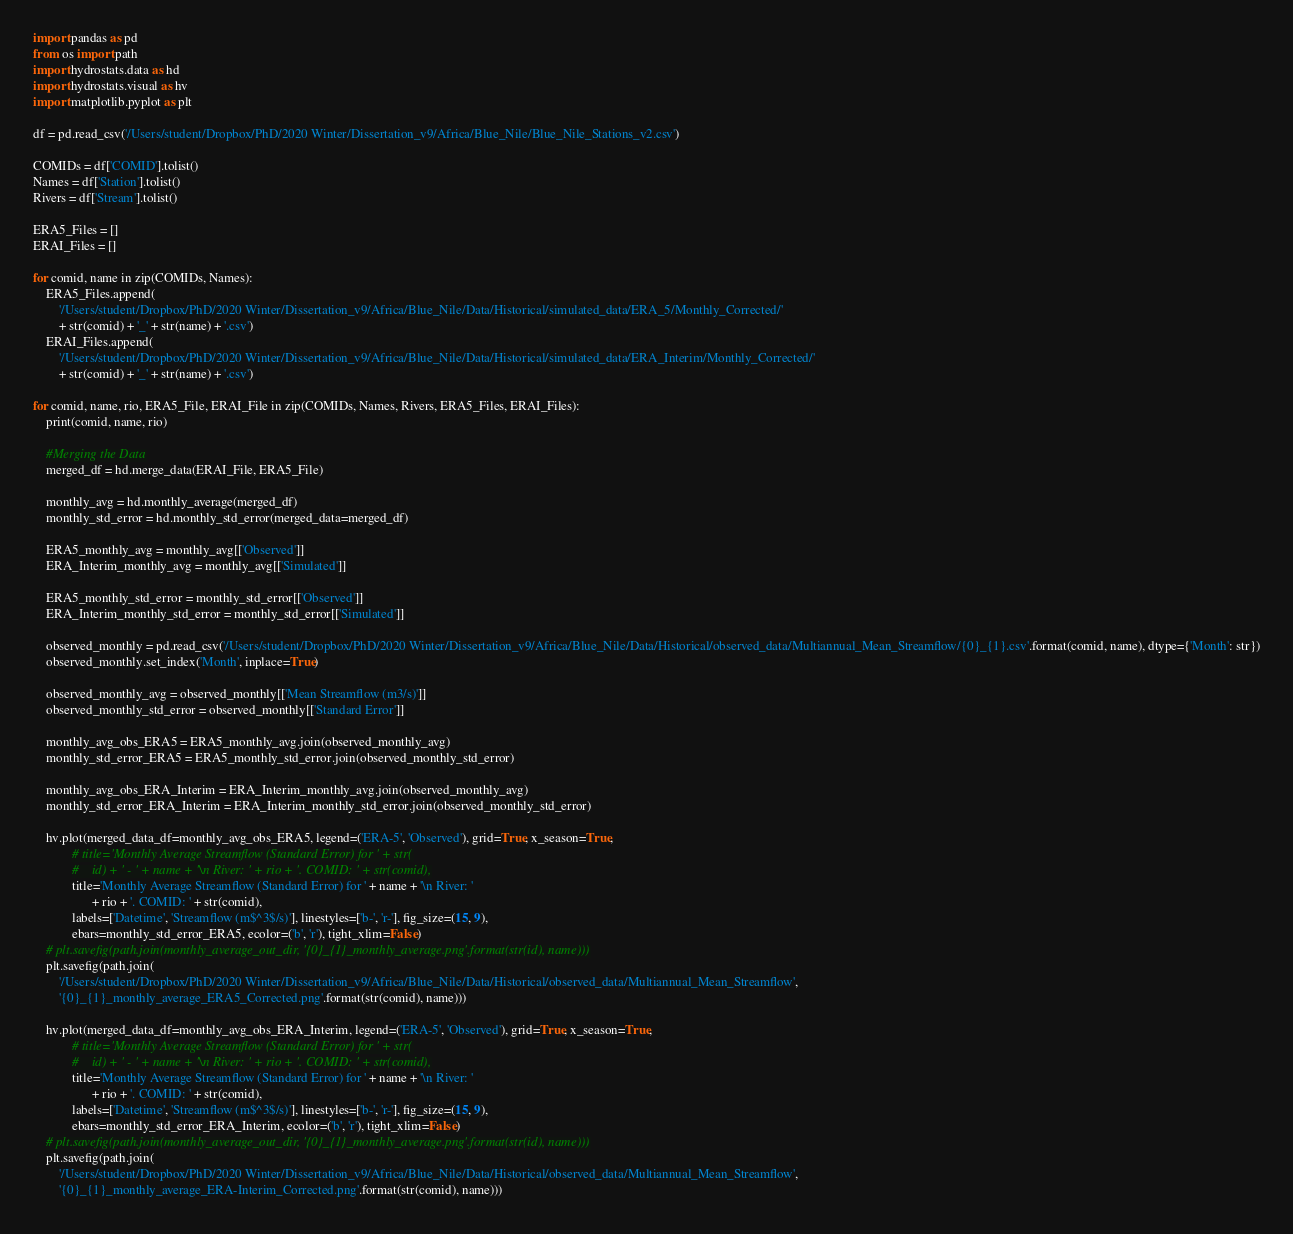Convert code to text. <code><loc_0><loc_0><loc_500><loc_500><_Python_>import pandas as pd
from os import path
import hydrostats.data as hd
import hydrostats.visual as hv
import matplotlib.pyplot as plt

df = pd.read_csv('/Users/student/Dropbox/PhD/2020 Winter/Dissertation_v9/Africa/Blue_Nile/Blue_Nile_Stations_v2.csv')

COMIDs = df['COMID'].tolist()
Names = df['Station'].tolist()
Rivers = df['Stream'].tolist()

ERA5_Files = []
ERAI_Files = []

for comid, name in zip(COMIDs, Names):
	ERA5_Files.append(
		'/Users/student/Dropbox/PhD/2020 Winter/Dissertation_v9/Africa/Blue_Nile/Data/Historical/simulated_data/ERA_5/Monthly_Corrected/'
		+ str(comid) + '_' + str(name) + '.csv')
	ERAI_Files.append(
		'/Users/student/Dropbox/PhD/2020 Winter/Dissertation_v9/Africa/Blue_Nile/Data/Historical/simulated_data/ERA_Interim/Monthly_Corrected/'
		+ str(comid) + '_' + str(name) + '.csv')

for comid, name, rio, ERA5_File, ERAI_File in zip(COMIDs, Names, Rivers, ERA5_Files, ERAI_Files):
	print(comid, name, rio)

	#Merging the Data
	merged_df = hd.merge_data(ERAI_File, ERA5_File)

	monthly_avg = hd.monthly_average(merged_df)
	monthly_std_error = hd.monthly_std_error(merged_data=merged_df)

	ERA5_monthly_avg = monthly_avg[['Observed']]
	ERA_Interim_monthly_avg = monthly_avg[['Simulated']]

	ERA5_monthly_std_error = monthly_std_error[['Observed']]
	ERA_Interim_monthly_std_error = monthly_std_error[['Simulated']]

	observed_monthly = pd.read_csv('/Users/student/Dropbox/PhD/2020 Winter/Dissertation_v9/Africa/Blue_Nile/Data/Historical/observed_data/Multiannual_Mean_Streamflow/{0}_{1}.csv'.format(comid, name), dtype={'Month': str})
	observed_monthly.set_index('Month', inplace=True)

	observed_monthly_avg = observed_monthly[['Mean Streamflow (m3/s)']]
	observed_monthly_std_error = observed_monthly[['Standard Error']]

	monthly_avg_obs_ERA5 = ERA5_monthly_avg.join(observed_monthly_avg)
	monthly_std_error_ERA5 = ERA5_monthly_std_error.join(observed_monthly_std_error)

	monthly_avg_obs_ERA_Interim = ERA_Interim_monthly_avg.join(observed_monthly_avg)
	monthly_std_error_ERA_Interim = ERA_Interim_monthly_std_error.join(observed_monthly_std_error)

	hv.plot(merged_data_df=monthly_avg_obs_ERA5, legend=('ERA-5', 'Observed'), grid=True, x_season=True,
	        # title='Monthly Average Streamflow (Standard Error) for ' + str(
	        #    id) + ' - ' + name + '\n River: ' + rio + '. COMID: ' + str(comid),
	        title='Monthly Average Streamflow (Standard Error) for ' + name + '\n River: '
	              + rio + '. COMID: ' + str(comid),
	        labels=['Datetime', 'Streamflow (m$^3$/s)'], linestyles=['b-', 'r-'], fig_size=(15, 9),
	        ebars=monthly_std_error_ERA5, ecolor=('b', 'r'), tight_xlim=False)
	# plt.savefig(path.join(monthly_average_out_dir, '{0}_{1}_monthly_average.png'.format(str(id), name)))
	plt.savefig(path.join(
		'/Users/student/Dropbox/PhD/2020 Winter/Dissertation_v9/Africa/Blue_Nile/Data/Historical/observed_data/Multiannual_Mean_Streamflow',
		'{0}_{1}_monthly_average_ERA5_Corrected.png'.format(str(comid), name)))

	hv.plot(merged_data_df=monthly_avg_obs_ERA_Interim, legend=('ERA-5', 'Observed'), grid=True, x_season=True,
	        # title='Monthly Average Streamflow (Standard Error) for ' + str(
	        #    id) + ' - ' + name + '\n River: ' + rio + '. COMID: ' + str(comid),
	        title='Monthly Average Streamflow (Standard Error) for ' + name + '\n River: '
	              + rio + '. COMID: ' + str(comid),
	        labels=['Datetime', 'Streamflow (m$^3$/s)'], linestyles=['b-', 'r-'], fig_size=(15, 9),
	        ebars=monthly_std_error_ERA_Interim, ecolor=('b', 'r'), tight_xlim=False)
	# plt.savefig(path.join(monthly_average_out_dir, '{0}_{1}_monthly_average.png'.format(str(id), name)))
	plt.savefig(path.join(
		'/Users/student/Dropbox/PhD/2020 Winter/Dissertation_v9/Africa/Blue_Nile/Data/Historical/observed_data/Multiannual_Mean_Streamflow',
		'{0}_{1}_monthly_average_ERA-Interim_Corrected.png'.format(str(comid), name)))
</code> 